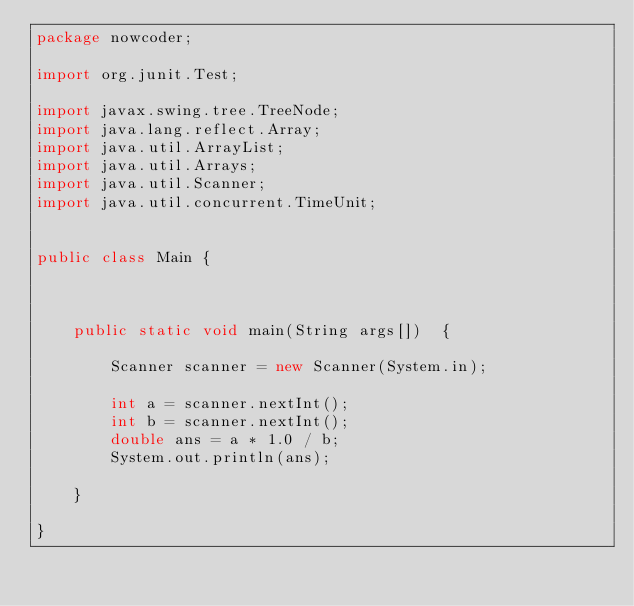Convert code to text. <code><loc_0><loc_0><loc_500><loc_500><_Java_>package nowcoder;

import org.junit.Test;

import javax.swing.tree.TreeNode;
import java.lang.reflect.Array;
import java.util.ArrayList;
import java.util.Arrays;
import java.util.Scanner;
import java.util.concurrent.TimeUnit;


public class Main {



    public static void main(String args[])  {

        Scanner scanner = new Scanner(System.in);

        int a = scanner.nextInt();
        int b = scanner.nextInt();
        double ans = a * 1.0 / b;
        System.out.println(ans);

    }

}</code> 